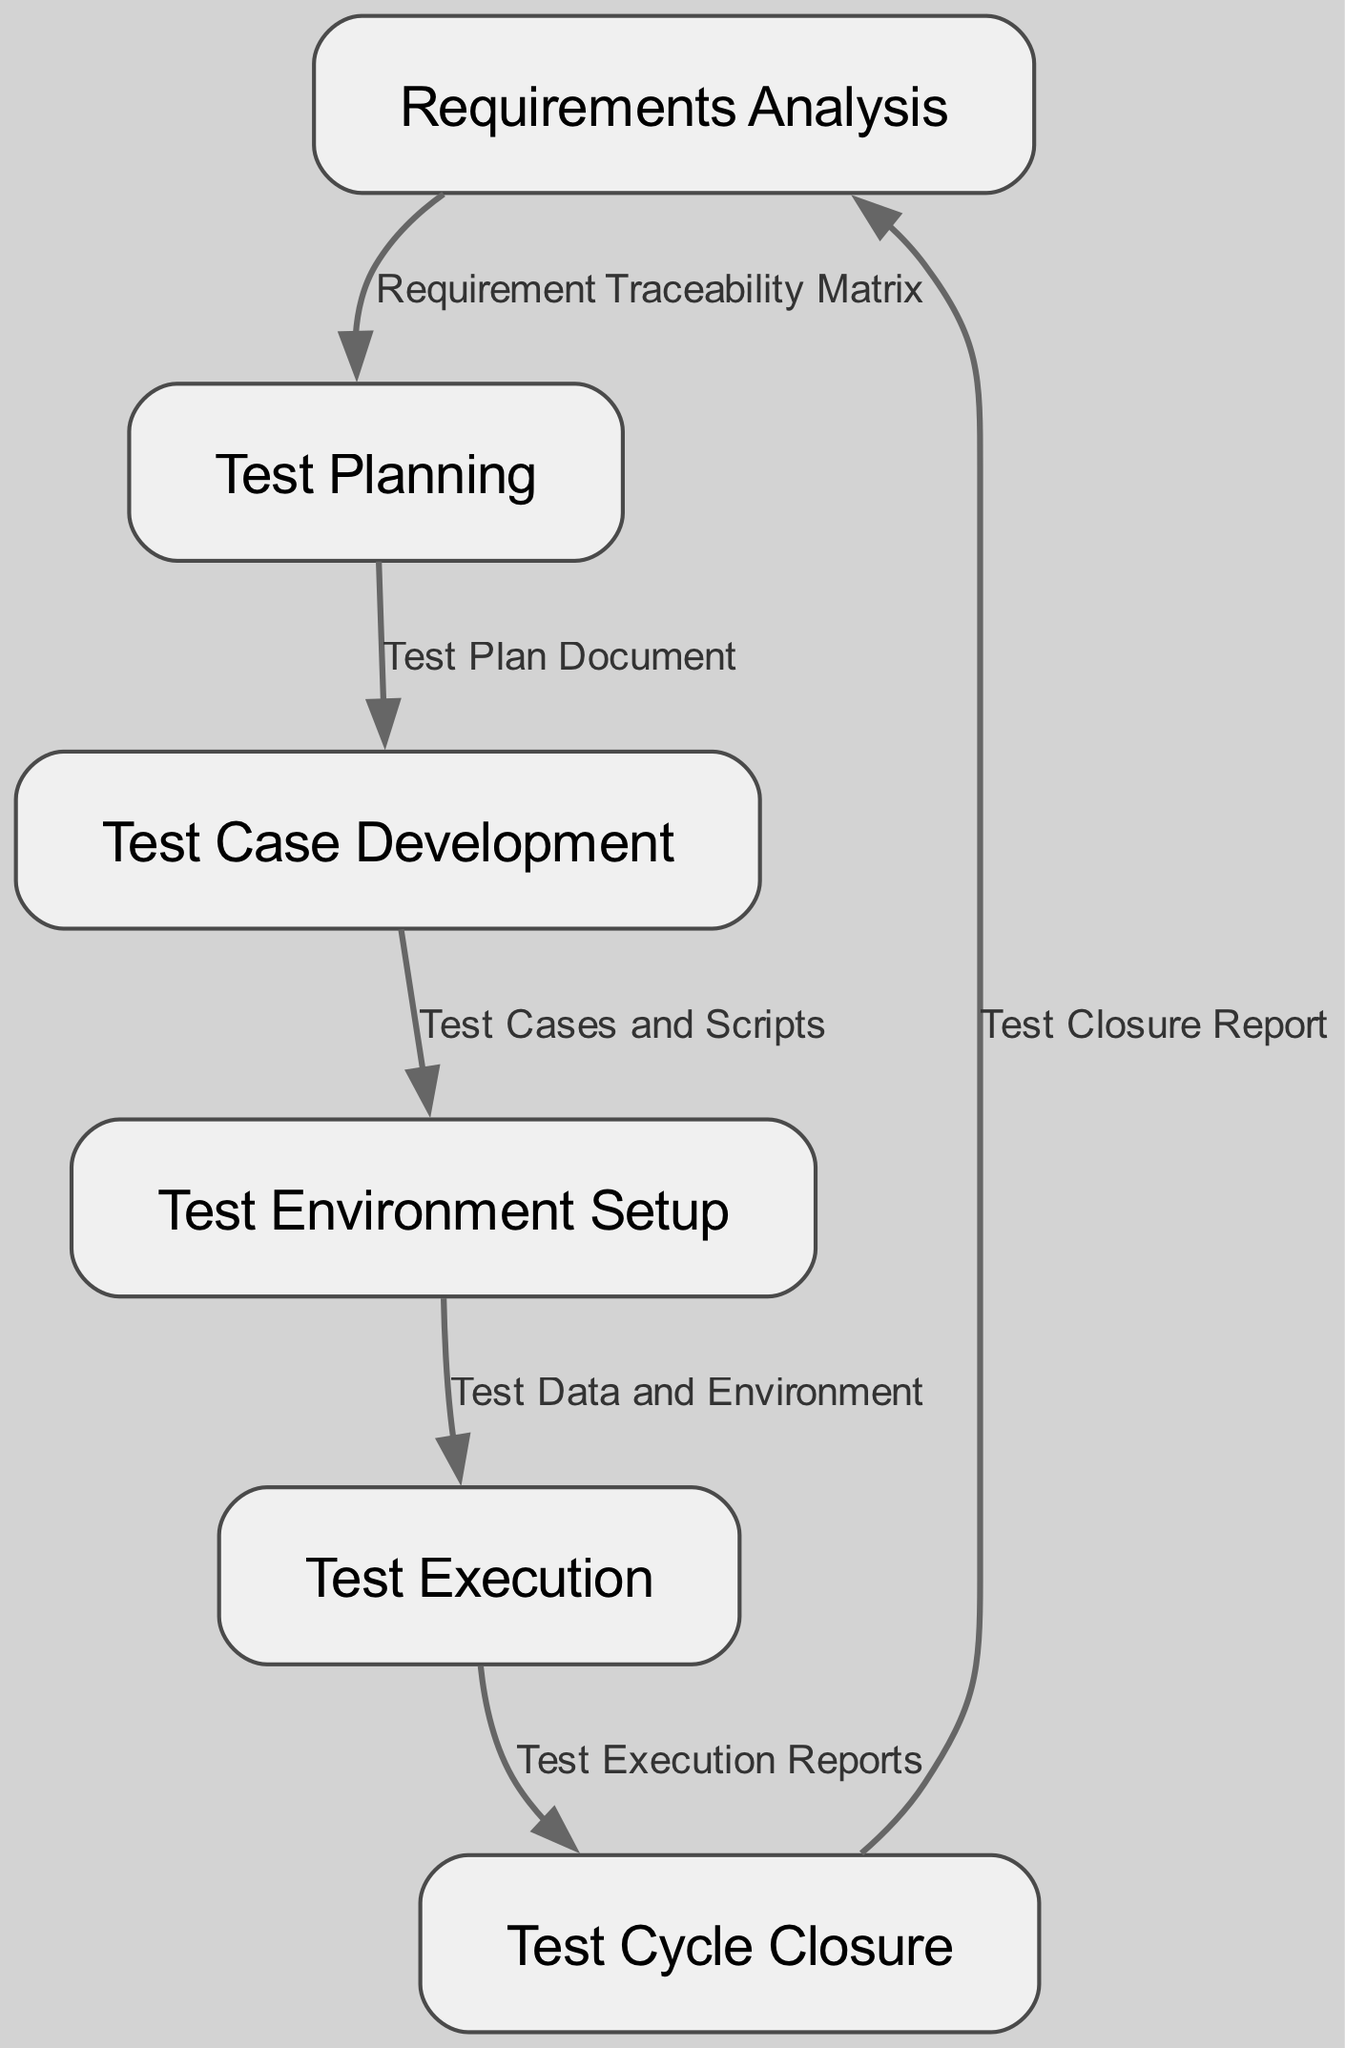What is the first phase in the Software Testing Life Cycle? The diagram indicates that the first phase is labeled as "Requirements Analysis". This information is directly found at the top of the diagram.
Answer: Requirements Analysis How many nodes are present in the diagram? By counting the distinct phases listed in the diagram, we can see there are a total of six nodes representing the phases of the Software Testing Life Cycle.
Answer: 6 What deliverable is produced after the Test Planning phase? The diagram indicates that the deliverable after the Test Planning phase is the "Test Plan Document", as shown by the edge connecting these two nodes.
Answer: Test Plan Document Which phase follows Test Case Development? By following the arrows in the diagram, it is clear that the phase that comes after Test Case Development is "Test Environment Setup". This is directly indicated by the flow from one node to another.
Answer: Test Environment Setup What is the relationship between Test Execution and Test Cycle Closure? The diagram shows a direct edge from "Test Execution" to "Test Cycle Closure" indicating the deliverable produced at this stage is the "Test Execution Reports". Thus, the relationship is that Test Execution informs the Test Cycle Closure phase.
Answer: Test Execution Reports In which phase is the Test Closure Report generated? According to the diagram, the Test Closure Report is produced during the Test Cycle Closure phase, which is the last phase before returning to Requirements Analysis.
Answer: Test Cycle Closure What is the last phase of the Software Testing Life Cycle as per the diagram? The diagram indicates that the last phase of the Software Testing Life Cycle is "Test Cycle Closure", as it is positioned at the end of the flow.
Answer: Test Cycle Closure How many edges connect the phases within the diagram? Counting the arrows connecting the nodes indicates there are a total of five edges in the diagram, each representing a deliverable between the phases.
Answer: 5 What is the deliverable that is traced from Requirements Analysis? The diagram specifies that the deliverable coming from Requirements Analysis is the "Requirement Traceability Matrix", which is directly associated with that initial phase.
Answer: Requirement Traceability Matrix 